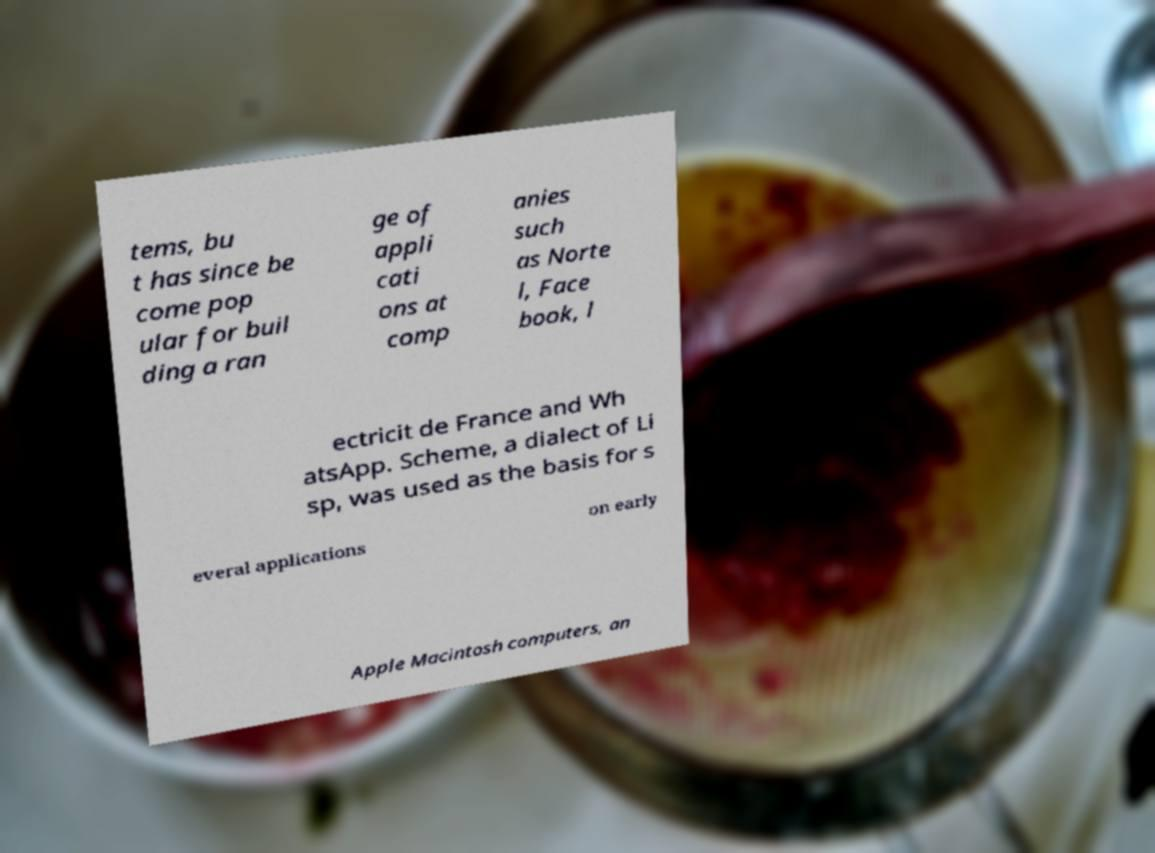Could you assist in decoding the text presented in this image and type it out clearly? tems, bu t has since be come pop ular for buil ding a ran ge of appli cati ons at comp anies such as Norte l, Face book, l ectricit de France and Wh atsApp. Scheme, a dialect of Li sp, was used as the basis for s everal applications on early Apple Macintosh computers, an 